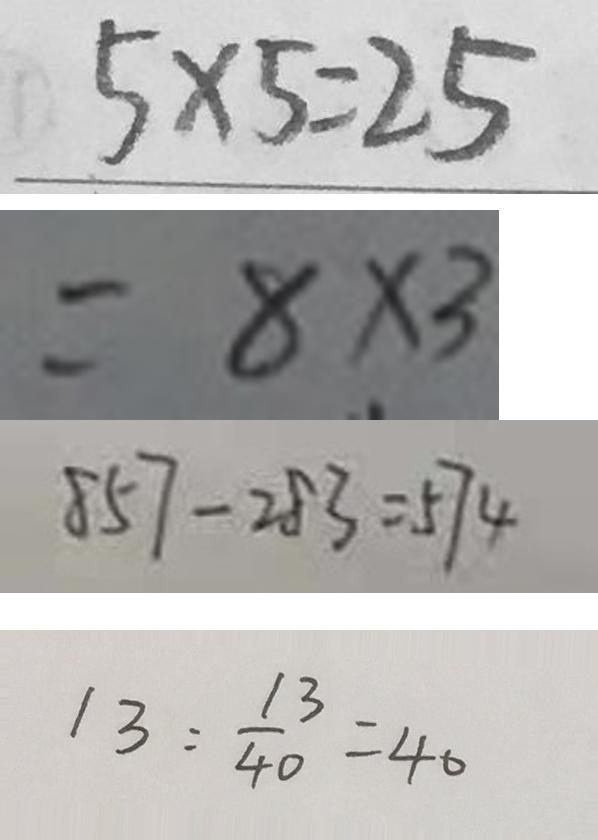Convert formula to latex. <formula><loc_0><loc_0><loc_500><loc_500>5 \times 5 = 2 5 
 = 8 \times 3 
 8 5 7 - 2 8 3 = 5 7 4 
 1 3 : \frac { 1 3 } { 4 0 } = 4 0</formula> 